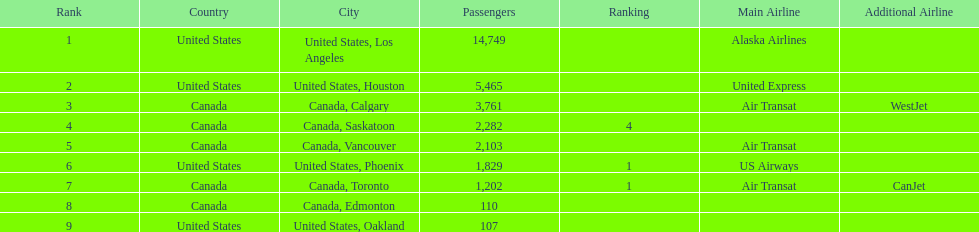How many airlines have a steady ranking? 4. 